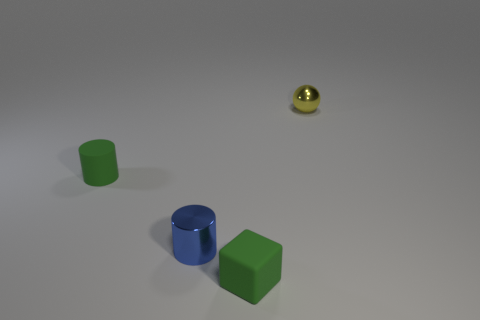What materials do the objects in the image seem to be made of? The materials of the objects appear to be quite different. The green cube and the cylinder look to have a rubber-like texture, suggesting they might be made of some sort of matte plastic or rubber material. The blue cylinder has a more reflective surface, indicating it might be made of a metallic material, and the tiny sphere has a polished, reflective finish that suggests it could be metallic as well. 